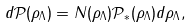Convert formula to latex. <formula><loc_0><loc_0><loc_500><loc_500>d \mathcal { P } ( \rho _ { \Lambda } ) = N ( \rho _ { \Lambda } ) \mathcal { P } _ { \ast } ( \rho _ { \Lambda } ) d \rho _ { \Lambda } ,</formula> 